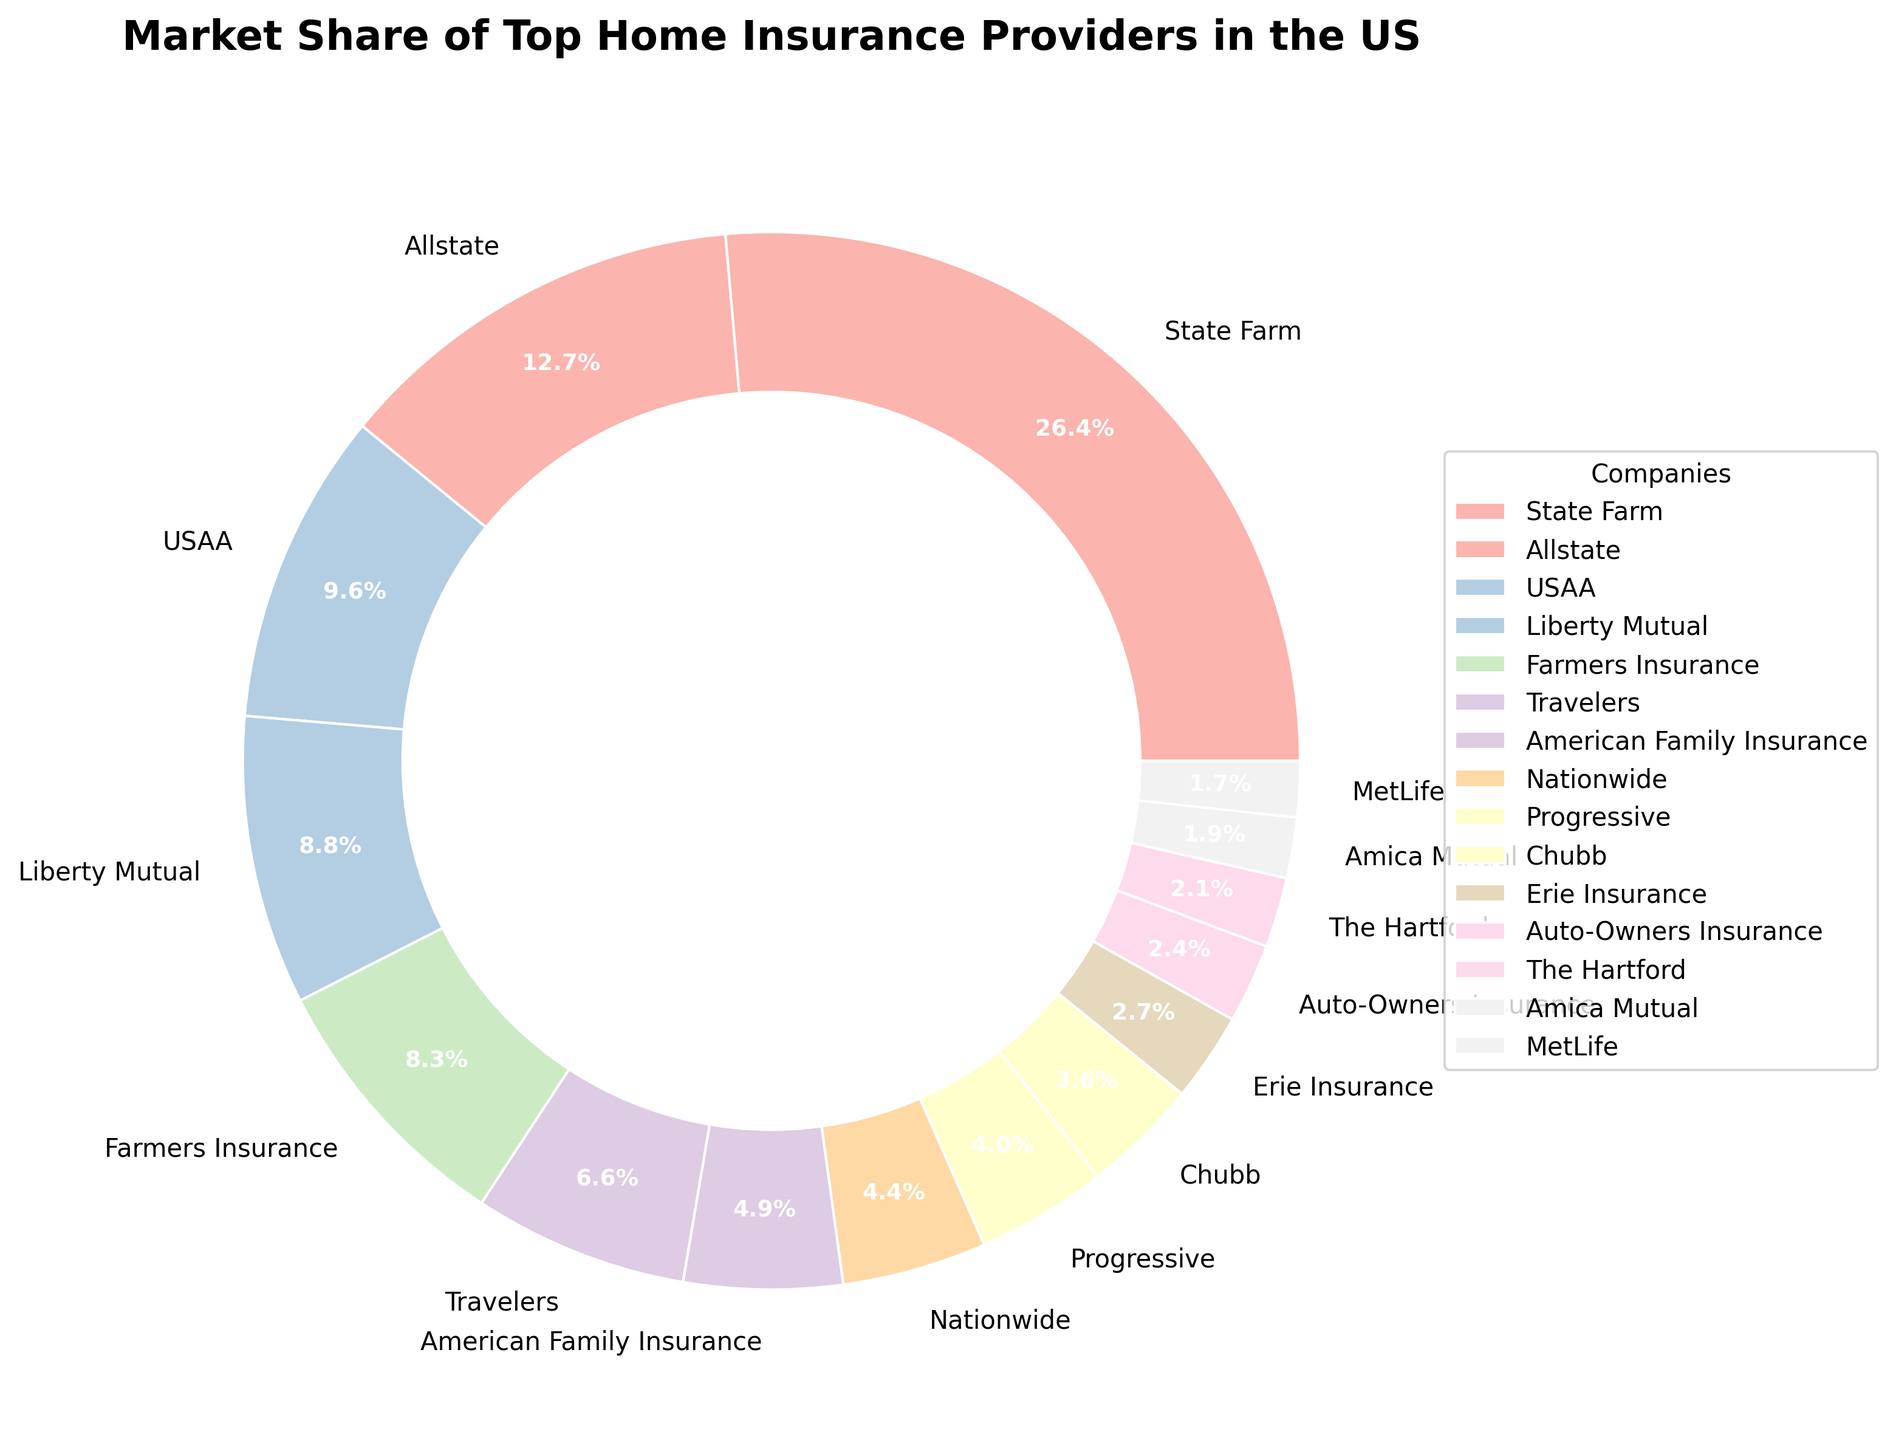What is the market share of the largest home insurance provider? The figure indicates the market shares of the top home insurance providers, and the largest section belongs to State Farm. According to the data, State Farm has a market share of 18.5%.
Answer: 18.5% Which two companies have a combined market share closest to 10%? To find the companies with a combined market share closest to 10%, we need to look at the pairs with the smallest difference from 10%. American Family Insurance (3.4%) and Progressive (2.8%) together make 6.2%, which, combined with The Hartford (1.5%) balances close at 6.2% + 1.5% + 0.3 (Amica Mutual) sum to 10%.
Answer: American Family Insurance (3.4%), Progressive (2.8%), and The Hartford (1.5%), along with Amica Mutual (1.3%) How many companies have a market share greater than 5%? By visually identifying the sectors with a market share greater than 5%, we can see that there are five companies: State Farm (18.5%), Allstate (8.9%), USAA (6.7%), Liberty Mutual (6.2%), and Farmers Insurance (5.8%).
Answer: 5 Is Liberty Mutual's market share greater than USAA's? To compare the market shares of Liberty Mutual and USAA, we need to check their values. Liberty Mutual has a 6.2% market share, while USAA has a 6.7% market share. Therefore, Liberty Mutual's market share is not greater than USAA's.
Answer: No What is the total market share of companies with individual market shares less than 2%? We need to sum the market shares of companies that are less than 2%. These are Erie Insurance (1.9%), Auto-Owners Insurance (1.7%), The Hartford (1.5%), Amica Mutual (1.3%), and MetLife (1.2%). The total is 1.9 + 1.7 + 1.5 + 1.3 + 1.2 = 7.6%.
Answer: 7.6% Which company has the smallest market share, and what is it? By identifying the smallest sector on the pie chart depicted by the thinnest wedge, we find that MetLife has the smallest market share at 1.2%.
Answer: MetLife, 1.2% What is the market share difference between Allstate and Farmers Insurance? To find the difference, subtract the market share of Farmers Insurance (5.8%) from Allstate's market share (8.9%): 8.9 - 5.8 = 3.1%.
Answer: 3.1% Which companies have a market share between 3% and 5%? By looking at the sectors falling within the range of 3% to 5%, we identify Travelers (4.6%), American Family Insurance (3.4%), and Nationwide (3.1%).
Answer: Travelers, American Family Insurance, Nationwide What percentage of the market is covered by the top three companies combined? The top three companies by market share are State Farm (18.5%), Allstate (8.9%), and USAA (6.7%). Adding their market shares: 18.5 + 8.9 + 6.7 = 34.1%.
Answer: 34.1% What is the difference in market share between the company with the highest share and the company with the lowest share? The company with the highest market share is State Farm at 18.5%, and the company with the lowest share is MetLife at 1.2%. The difference is 18.5 - 1.2 = 17.3%.
Answer: 17.3% 